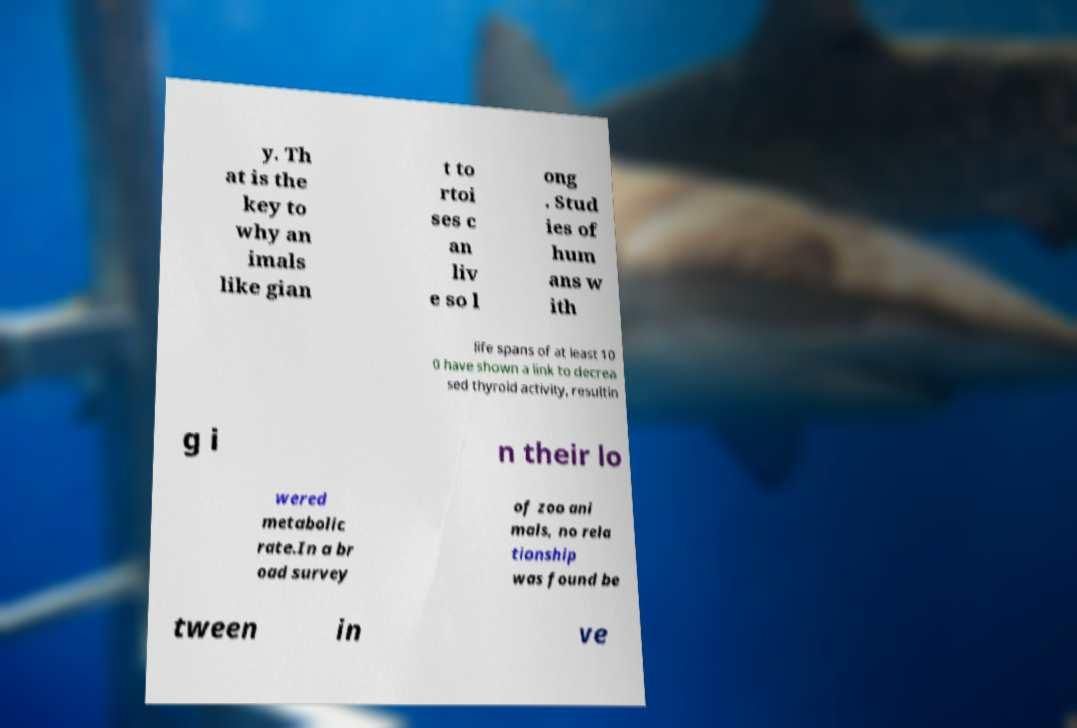Could you extract and type out the text from this image? y. Th at is the key to why an imals like gian t to rtoi ses c an liv e so l ong . Stud ies of hum ans w ith life spans of at least 10 0 have shown a link to decrea sed thyroid activity, resultin g i n their lo wered metabolic rate.In a br oad survey of zoo ani mals, no rela tionship was found be tween in ve 